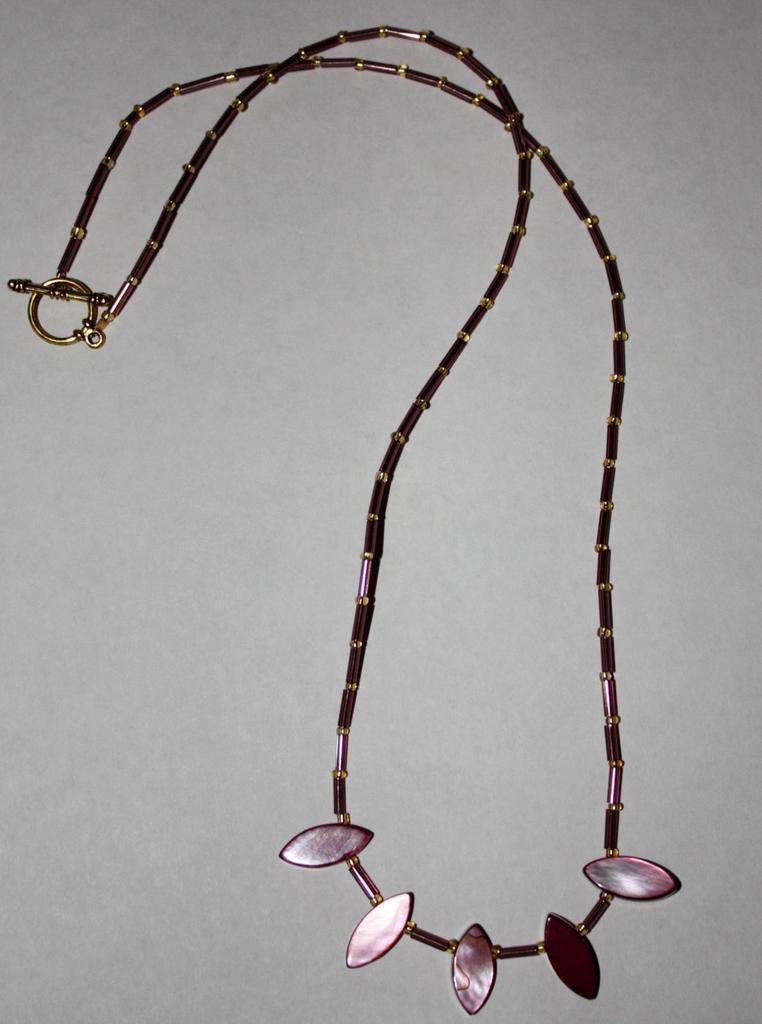What type of jewelry is visible in the image? There is a neck chain in the image. Can you describe the design of the neck chain? The neck chain has a design. Where is the neck chain located in the image? The neck chain is on a surface. How many kittens are playing with the fish in the image? There are no kittens or fish present in the image; it only features a neck chain. 